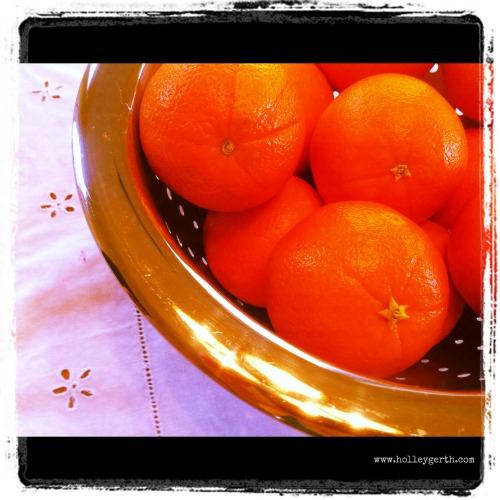What is the netting holding the fruit made of?
Be succinct. Metal. Does the container the oranges are in have holes in it?
Short answer required. Yes. Is there only one fruit?
Give a very brief answer. No. What is the photographer's website?
Be succinct. Holly gerthcom. What color is the fruits?
Give a very brief answer. Orange. 